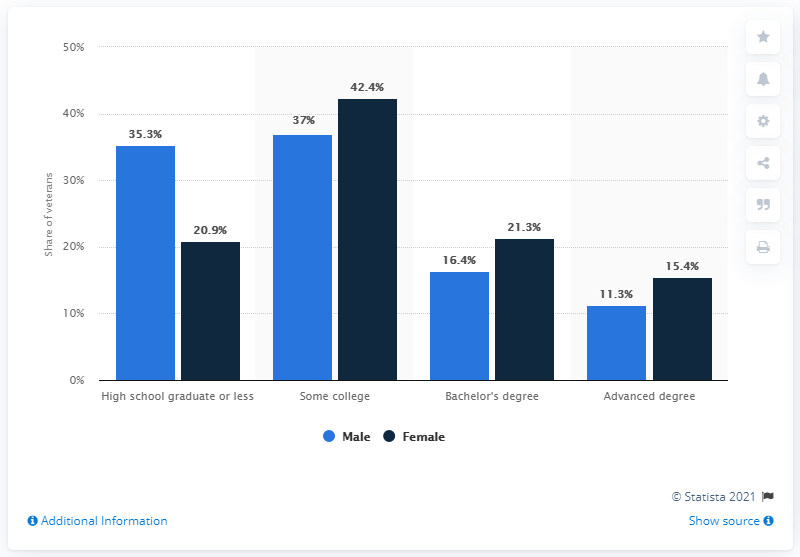Indicate a few pertinent items in this graphic. According to data from 2017, a significant proportion of female veterans, specifically 21.3%, held a Bachelor's degree. 